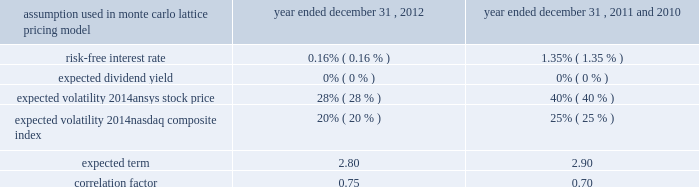Under the terms of the ansys , inc .
Long-term incentive plan , in the first quarter of 2012 , 2011 and 2010 , the company granted 100000 , 92500 and 80500 performance-based restricted stock units , respectively .
Vesting of the full award or a portion thereof is based on the company 2019s performance as measured by total shareholder return relative to the median percentage appreciation of the nasdaq composite index over a specified measurement period , subject to each participant 2019s continued employment with the company through the conclusion of the measurement period .
The measurement period for the restricted stock units granted pursuant to the long-term incentive plan is a three-year period beginning january 1 of the year of the grant .
Each restricted stock unit relates to one share of the company 2019s common stock .
The value of each restricted stock unit granted in 2012 , 2011 and 2010 was estimated on the grant date to be $ 33.16 , $ 32.05 and $ 25.00 , respectively .
The estimate of the grant-date value of the restricted stock units was made using a monte carlo simulation model .
The determination of the fair value of the awards was affected by the grant date and a number of variables , each of which has been identified in the chart below .
Share-based compensation expense based on the fair value of the award is being recorded from the grant date through the conclusion of the three-year measurement period .
On december 31 , 2012 , employees earned 76500 restricted stock units , which will be issued in the first quarter of 2013 .
Total compensation expense associated with the awards recorded for the years ended december 31 , 2012 , 2011 and 2010 was $ 2.6 million , $ 1.6 million and $ 590000 , respectively .
Total compensation expense associated with the awards granted for the years ending december 31 , 2013 and 2014 is expected to be $ 2.2 million and $ 1.2 million , respectively. .
In accordance with the merger agreement , the company granted performance-based restricted stock units to key members of apache management and employees , with a maximum value of $ 13.0 million to be earned annually over a three-fiscal-year period beginning january 1 , 2012 .
Additional details regarding these awards are provided within note 3 .
14 .
Stock repurchase program in february 2012 , ansys announced that its board of directors approved an increase to its authorized stock repurchase program .
Under the company 2019s stock repurchase program , ansys repurchased 1.5 million shares during the year ended december 31 , 2012 at an average price per share of $ 63.65 , for a total cost of $ 95.5 million .
During the year ended december 31 , 2011 , the company repurchased 247443 shares at an average price per share of $ 51.34 , for a total cost of $ 12.7 million .
As of december 31 , 2012 , 1.5 million shares remained authorized for repurchase under the program .
15 .
Employee stock purchase plan the company 2019s 1996 employee stock purchase plan ( the 201cpurchase plan 201d ) was adopted by the board of directors on april 19 , 1996 and was subsequently approved by the company 2019s stockholders .
The stockholders approved an amendment to the purchase plan on may 6 , 2004 to increase the number of shares available for offerings to 1.6 million shares .
The purchase plan was amended and restated in 2007 .
The purchase plan is administered by the compensation committee .
Offerings under the purchase plan commence on each february 1 and august 1 , and have a duration of six months .
An employee who owns or is deemed to own shares of stock representing in excess of 5% ( 5 % ) of the combined voting power of all classes of stock of the company may not participate in the purchase plan .
During each offering , an eligible employee may purchase shares under the purchase plan by authorizing payroll deductions of up to 10% ( 10 % ) of his or her cash compensation during the offering period .
The maximum number of shares that may be purchased by any participating employee during any offering period is limited to 3840 shares ( as adjusted by the compensation committee from time to time ) .
Unless the employee has previously withdrawn from the offering , his accumulated payroll deductions will be used to purchase common stock on the last business day of the period at a price equal to 90% ( 90 % ) of the fair market value of the common stock on the first or last day of the offering period , whichever is lower .
Under applicable tax rules , an employee may purchase no more than $ 25000 worth of common stock in any calendar year .
At december 31 , 2012 , 1233385 shares of common stock had been issued under the purchase plan , of which 1184082 were issued as of december 31 , 2011 .
The total compensation expense recorded under the purchase plan during the years ended december 31 , 2012 , 2011 and 2010 was $ 710000 , $ 650000 and $ 500000 , respectively .
Table of contents .
What was the average shares granted as part of the long-term incentive plan , in the first quarter of 2012 , 2011 and 2010\\n? 
Computations: ((((100000 + 92500) + (100000 + 92500)) + 3) / 2)
Answer: 192501.5. Under the terms of the ansys , inc .
Long-term incentive plan , in the first quarter of 2012 , 2011 and 2010 , the company granted 100000 , 92500 and 80500 performance-based restricted stock units , respectively .
Vesting of the full award or a portion thereof is based on the company 2019s performance as measured by total shareholder return relative to the median percentage appreciation of the nasdaq composite index over a specified measurement period , subject to each participant 2019s continued employment with the company through the conclusion of the measurement period .
The measurement period for the restricted stock units granted pursuant to the long-term incentive plan is a three-year period beginning january 1 of the year of the grant .
Each restricted stock unit relates to one share of the company 2019s common stock .
The value of each restricted stock unit granted in 2012 , 2011 and 2010 was estimated on the grant date to be $ 33.16 , $ 32.05 and $ 25.00 , respectively .
The estimate of the grant-date value of the restricted stock units was made using a monte carlo simulation model .
The determination of the fair value of the awards was affected by the grant date and a number of variables , each of which has been identified in the chart below .
Share-based compensation expense based on the fair value of the award is being recorded from the grant date through the conclusion of the three-year measurement period .
On december 31 , 2012 , employees earned 76500 restricted stock units , which will be issued in the first quarter of 2013 .
Total compensation expense associated with the awards recorded for the years ended december 31 , 2012 , 2011 and 2010 was $ 2.6 million , $ 1.6 million and $ 590000 , respectively .
Total compensation expense associated with the awards granted for the years ending december 31 , 2013 and 2014 is expected to be $ 2.2 million and $ 1.2 million , respectively. .
In accordance with the merger agreement , the company granted performance-based restricted stock units to key members of apache management and employees , with a maximum value of $ 13.0 million to be earned annually over a three-fiscal-year period beginning january 1 , 2012 .
Additional details regarding these awards are provided within note 3 .
14 .
Stock repurchase program in february 2012 , ansys announced that its board of directors approved an increase to its authorized stock repurchase program .
Under the company 2019s stock repurchase program , ansys repurchased 1.5 million shares during the year ended december 31 , 2012 at an average price per share of $ 63.65 , for a total cost of $ 95.5 million .
During the year ended december 31 , 2011 , the company repurchased 247443 shares at an average price per share of $ 51.34 , for a total cost of $ 12.7 million .
As of december 31 , 2012 , 1.5 million shares remained authorized for repurchase under the program .
15 .
Employee stock purchase plan the company 2019s 1996 employee stock purchase plan ( the 201cpurchase plan 201d ) was adopted by the board of directors on april 19 , 1996 and was subsequently approved by the company 2019s stockholders .
The stockholders approved an amendment to the purchase plan on may 6 , 2004 to increase the number of shares available for offerings to 1.6 million shares .
The purchase plan was amended and restated in 2007 .
The purchase plan is administered by the compensation committee .
Offerings under the purchase plan commence on each february 1 and august 1 , and have a duration of six months .
An employee who owns or is deemed to own shares of stock representing in excess of 5% ( 5 % ) of the combined voting power of all classes of stock of the company may not participate in the purchase plan .
During each offering , an eligible employee may purchase shares under the purchase plan by authorizing payroll deductions of up to 10% ( 10 % ) of his or her cash compensation during the offering period .
The maximum number of shares that may be purchased by any participating employee during any offering period is limited to 3840 shares ( as adjusted by the compensation committee from time to time ) .
Unless the employee has previously withdrawn from the offering , his accumulated payroll deductions will be used to purchase common stock on the last business day of the period at a price equal to 90% ( 90 % ) of the fair market value of the common stock on the first or last day of the offering period , whichever is lower .
Under applicable tax rules , an employee may purchase no more than $ 25000 worth of common stock in any calendar year .
At december 31 , 2012 , 1233385 shares of common stock had been issued under the purchase plan , of which 1184082 were issued as of december 31 , 2011 .
The total compensation expense recorded under the purchase plan during the years ended december 31 , 2012 , 2011 and 2010 was $ 710000 , $ 650000 and $ 500000 , respectively .
Table of contents .
What was the average total compensation expense associated with the awards granted for the years ending december 31 , 2013 and 2014? 
Computations: ((2.2 + 1.2) / 2)
Answer: 1.7. 